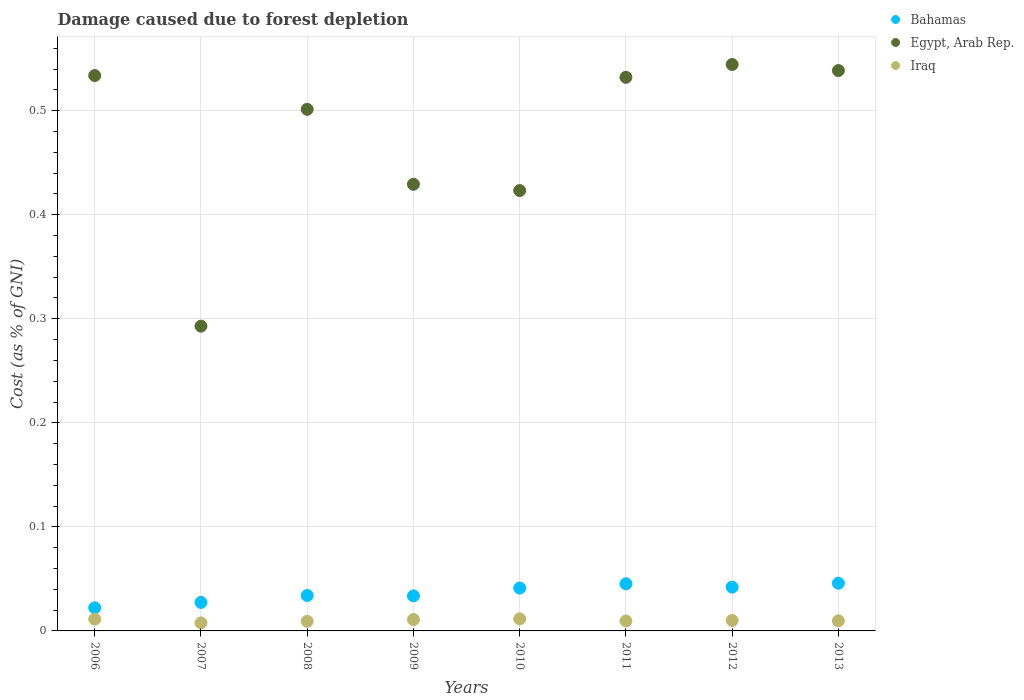How many different coloured dotlines are there?
Your answer should be very brief. 3. What is the cost of damage caused due to forest depletion in Egypt, Arab Rep. in 2011?
Ensure brevity in your answer.  0.53. Across all years, what is the maximum cost of damage caused due to forest depletion in Egypt, Arab Rep.?
Keep it short and to the point. 0.54. Across all years, what is the minimum cost of damage caused due to forest depletion in Egypt, Arab Rep.?
Offer a terse response. 0.29. In which year was the cost of damage caused due to forest depletion in Bahamas minimum?
Your response must be concise. 2006. What is the total cost of damage caused due to forest depletion in Iraq in the graph?
Offer a terse response. 0.08. What is the difference between the cost of damage caused due to forest depletion in Iraq in 2007 and that in 2008?
Provide a short and direct response. -0. What is the difference between the cost of damage caused due to forest depletion in Egypt, Arab Rep. in 2013 and the cost of damage caused due to forest depletion in Iraq in 2009?
Provide a succinct answer. 0.53. What is the average cost of damage caused due to forest depletion in Bahamas per year?
Provide a succinct answer. 0.04. In the year 2012, what is the difference between the cost of damage caused due to forest depletion in Egypt, Arab Rep. and cost of damage caused due to forest depletion in Bahamas?
Offer a very short reply. 0.5. In how many years, is the cost of damage caused due to forest depletion in Egypt, Arab Rep. greater than 0.46 %?
Keep it short and to the point. 5. What is the ratio of the cost of damage caused due to forest depletion in Iraq in 2010 to that in 2013?
Your response must be concise. 1.2. What is the difference between the highest and the second highest cost of damage caused due to forest depletion in Egypt, Arab Rep.?
Your response must be concise. 0.01. What is the difference between the highest and the lowest cost of damage caused due to forest depletion in Iraq?
Ensure brevity in your answer.  0. Is the sum of the cost of damage caused due to forest depletion in Bahamas in 2009 and 2012 greater than the maximum cost of damage caused due to forest depletion in Iraq across all years?
Provide a short and direct response. Yes. Is it the case that in every year, the sum of the cost of damage caused due to forest depletion in Iraq and cost of damage caused due to forest depletion in Egypt, Arab Rep.  is greater than the cost of damage caused due to forest depletion in Bahamas?
Your answer should be very brief. Yes. Is the cost of damage caused due to forest depletion in Egypt, Arab Rep. strictly less than the cost of damage caused due to forest depletion in Iraq over the years?
Offer a very short reply. No. How many dotlines are there?
Make the answer very short. 3. What is the difference between two consecutive major ticks on the Y-axis?
Make the answer very short. 0.1. Are the values on the major ticks of Y-axis written in scientific E-notation?
Keep it short and to the point. No. Does the graph contain grids?
Provide a short and direct response. Yes. Where does the legend appear in the graph?
Offer a very short reply. Top right. What is the title of the graph?
Your response must be concise. Damage caused due to forest depletion. Does "Least developed countries" appear as one of the legend labels in the graph?
Offer a very short reply. No. What is the label or title of the Y-axis?
Offer a very short reply. Cost (as % of GNI). What is the Cost (as % of GNI) in Bahamas in 2006?
Keep it short and to the point. 0.02. What is the Cost (as % of GNI) in Egypt, Arab Rep. in 2006?
Keep it short and to the point. 0.53. What is the Cost (as % of GNI) of Iraq in 2006?
Offer a very short reply. 0.01. What is the Cost (as % of GNI) of Bahamas in 2007?
Provide a short and direct response. 0.03. What is the Cost (as % of GNI) of Egypt, Arab Rep. in 2007?
Offer a very short reply. 0.29. What is the Cost (as % of GNI) in Iraq in 2007?
Give a very brief answer. 0.01. What is the Cost (as % of GNI) in Bahamas in 2008?
Keep it short and to the point. 0.03. What is the Cost (as % of GNI) of Egypt, Arab Rep. in 2008?
Your response must be concise. 0.5. What is the Cost (as % of GNI) in Iraq in 2008?
Your response must be concise. 0.01. What is the Cost (as % of GNI) of Bahamas in 2009?
Give a very brief answer. 0.03. What is the Cost (as % of GNI) in Egypt, Arab Rep. in 2009?
Your answer should be compact. 0.43. What is the Cost (as % of GNI) of Iraq in 2009?
Give a very brief answer. 0.01. What is the Cost (as % of GNI) in Bahamas in 2010?
Provide a succinct answer. 0.04. What is the Cost (as % of GNI) in Egypt, Arab Rep. in 2010?
Offer a terse response. 0.42. What is the Cost (as % of GNI) in Iraq in 2010?
Your response must be concise. 0.01. What is the Cost (as % of GNI) in Bahamas in 2011?
Your answer should be very brief. 0.05. What is the Cost (as % of GNI) of Egypt, Arab Rep. in 2011?
Provide a short and direct response. 0.53. What is the Cost (as % of GNI) in Iraq in 2011?
Give a very brief answer. 0.01. What is the Cost (as % of GNI) of Bahamas in 2012?
Keep it short and to the point. 0.04. What is the Cost (as % of GNI) in Egypt, Arab Rep. in 2012?
Keep it short and to the point. 0.54. What is the Cost (as % of GNI) in Iraq in 2012?
Give a very brief answer. 0.01. What is the Cost (as % of GNI) of Bahamas in 2013?
Offer a very short reply. 0.05. What is the Cost (as % of GNI) in Egypt, Arab Rep. in 2013?
Offer a very short reply. 0.54. What is the Cost (as % of GNI) in Iraq in 2013?
Give a very brief answer. 0.01. Across all years, what is the maximum Cost (as % of GNI) in Bahamas?
Your answer should be compact. 0.05. Across all years, what is the maximum Cost (as % of GNI) in Egypt, Arab Rep.?
Offer a terse response. 0.54. Across all years, what is the maximum Cost (as % of GNI) of Iraq?
Offer a terse response. 0.01. Across all years, what is the minimum Cost (as % of GNI) of Bahamas?
Your response must be concise. 0.02. Across all years, what is the minimum Cost (as % of GNI) of Egypt, Arab Rep.?
Provide a succinct answer. 0.29. Across all years, what is the minimum Cost (as % of GNI) in Iraq?
Your response must be concise. 0.01. What is the total Cost (as % of GNI) in Bahamas in the graph?
Give a very brief answer. 0.29. What is the total Cost (as % of GNI) in Egypt, Arab Rep. in the graph?
Ensure brevity in your answer.  3.8. What is the total Cost (as % of GNI) in Iraq in the graph?
Ensure brevity in your answer.  0.08. What is the difference between the Cost (as % of GNI) in Bahamas in 2006 and that in 2007?
Give a very brief answer. -0.01. What is the difference between the Cost (as % of GNI) in Egypt, Arab Rep. in 2006 and that in 2007?
Provide a short and direct response. 0.24. What is the difference between the Cost (as % of GNI) of Iraq in 2006 and that in 2007?
Your answer should be compact. 0. What is the difference between the Cost (as % of GNI) of Bahamas in 2006 and that in 2008?
Keep it short and to the point. -0.01. What is the difference between the Cost (as % of GNI) in Egypt, Arab Rep. in 2006 and that in 2008?
Your answer should be compact. 0.03. What is the difference between the Cost (as % of GNI) in Iraq in 2006 and that in 2008?
Ensure brevity in your answer.  0. What is the difference between the Cost (as % of GNI) of Bahamas in 2006 and that in 2009?
Your response must be concise. -0.01. What is the difference between the Cost (as % of GNI) in Egypt, Arab Rep. in 2006 and that in 2009?
Your answer should be compact. 0.1. What is the difference between the Cost (as % of GNI) of Iraq in 2006 and that in 2009?
Ensure brevity in your answer.  0. What is the difference between the Cost (as % of GNI) of Bahamas in 2006 and that in 2010?
Offer a terse response. -0.02. What is the difference between the Cost (as % of GNI) in Egypt, Arab Rep. in 2006 and that in 2010?
Keep it short and to the point. 0.11. What is the difference between the Cost (as % of GNI) of Iraq in 2006 and that in 2010?
Provide a short and direct response. -0. What is the difference between the Cost (as % of GNI) of Bahamas in 2006 and that in 2011?
Your response must be concise. -0.02. What is the difference between the Cost (as % of GNI) of Egypt, Arab Rep. in 2006 and that in 2011?
Ensure brevity in your answer.  0. What is the difference between the Cost (as % of GNI) of Iraq in 2006 and that in 2011?
Give a very brief answer. 0. What is the difference between the Cost (as % of GNI) of Bahamas in 2006 and that in 2012?
Offer a very short reply. -0.02. What is the difference between the Cost (as % of GNI) of Egypt, Arab Rep. in 2006 and that in 2012?
Your response must be concise. -0.01. What is the difference between the Cost (as % of GNI) in Iraq in 2006 and that in 2012?
Your answer should be very brief. 0. What is the difference between the Cost (as % of GNI) in Bahamas in 2006 and that in 2013?
Make the answer very short. -0.02. What is the difference between the Cost (as % of GNI) in Egypt, Arab Rep. in 2006 and that in 2013?
Offer a terse response. -0. What is the difference between the Cost (as % of GNI) of Iraq in 2006 and that in 2013?
Provide a short and direct response. 0. What is the difference between the Cost (as % of GNI) in Bahamas in 2007 and that in 2008?
Ensure brevity in your answer.  -0.01. What is the difference between the Cost (as % of GNI) in Egypt, Arab Rep. in 2007 and that in 2008?
Your answer should be very brief. -0.21. What is the difference between the Cost (as % of GNI) of Iraq in 2007 and that in 2008?
Ensure brevity in your answer.  -0. What is the difference between the Cost (as % of GNI) of Bahamas in 2007 and that in 2009?
Make the answer very short. -0.01. What is the difference between the Cost (as % of GNI) of Egypt, Arab Rep. in 2007 and that in 2009?
Give a very brief answer. -0.14. What is the difference between the Cost (as % of GNI) of Iraq in 2007 and that in 2009?
Provide a succinct answer. -0. What is the difference between the Cost (as % of GNI) in Bahamas in 2007 and that in 2010?
Give a very brief answer. -0.01. What is the difference between the Cost (as % of GNI) of Egypt, Arab Rep. in 2007 and that in 2010?
Ensure brevity in your answer.  -0.13. What is the difference between the Cost (as % of GNI) in Iraq in 2007 and that in 2010?
Keep it short and to the point. -0. What is the difference between the Cost (as % of GNI) of Bahamas in 2007 and that in 2011?
Make the answer very short. -0.02. What is the difference between the Cost (as % of GNI) in Egypt, Arab Rep. in 2007 and that in 2011?
Offer a very short reply. -0.24. What is the difference between the Cost (as % of GNI) of Iraq in 2007 and that in 2011?
Make the answer very short. -0. What is the difference between the Cost (as % of GNI) of Bahamas in 2007 and that in 2012?
Provide a short and direct response. -0.01. What is the difference between the Cost (as % of GNI) in Egypt, Arab Rep. in 2007 and that in 2012?
Keep it short and to the point. -0.25. What is the difference between the Cost (as % of GNI) of Iraq in 2007 and that in 2012?
Provide a short and direct response. -0. What is the difference between the Cost (as % of GNI) in Bahamas in 2007 and that in 2013?
Keep it short and to the point. -0.02. What is the difference between the Cost (as % of GNI) in Egypt, Arab Rep. in 2007 and that in 2013?
Keep it short and to the point. -0.25. What is the difference between the Cost (as % of GNI) of Iraq in 2007 and that in 2013?
Offer a very short reply. -0. What is the difference between the Cost (as % of GNI) of Bahamas in 2008 and that in 2009?
Keep it short and to the point. 0. What is the difference between the Cost (as % of GNI) in Egypt, Arab Rep. in 2008 and that in 2009?
Keep it short and to the point. 0.07. What is the difference between the Cost (as % of GNI) of Iraq in 2008 and that in 2009?
Your answer should be compact. -0. What is the difference between the Cost (as % of GNI) of Bahamas in 2008 and that in 2010?
Provide a short and direct response. -0.01. What is the difference between the Cost (as % of GNI) of Egypt, Arab Rep. in 2008 and that in 2010?
Give a very brief answer. 0.08. What is the difference between the Cost (as % of GNI) in Iraq in 2008 and that in 2010?
Make the answer very short. -0. What is the difference between the Cost (as % of GNI) in Bahamas in 2008 and that in 2011?
Offer a terse response. -0.01. What is the difference between the Cost (as % of GNI) in Egypt, Arab Rep. in 2008 and that in 2011?
Your response must be concise. -0.03. What is the difference between the Cost (as % of GNI) in Iraq in 2008 and that in 2011?
Your response must be concise. -0. What is the difference between the Cost (as % of GNI) of Bahamas in 2008 and that in 2012?
Your answer should be compact. -0.01. What is the difference between the Cost (as % of GNI) of Egypt, Arab Rep. in 2008 and that in 2012?
Offer a very short reply. -0.04. What is the difference between the Cost (as % of GNI) of Iraq in 2008 and that in 2012?
Provide a short and direct response. -0. What is the difference between the Cost (as % of GNI) of Bahamas in 2008 and that in 2013?
Provide a succinct answer. -0.01. What is the difference between the Cost (as % of GNI) of Egypt, Arab Rep. in 2008 and that in 2013?
Provide a short and direct response. -0.04. What is the difference between the Cost (as % of GNI) in Iraq in 2008 and that in 2013?
Offer a very short reply. -0. What is the difference between the Cost (as % of GNI) of Bahamas in 2009 and that in 2010?
Keep it short and to the point. -0.01. What is the difference between the Cost (as % of GNI) in Egypt, Arab Rep. in 2009 and that in 2010?
Offer a very short reply. 0.01. What is the difference between the Cost (as % of GNI) in Iraq in 2009 and that in 2010?
Give a very brief answer. -0. What is the difference between the Cost (as % of GNI) in Bahamas in 2009 and that in 2011?
Provide a succinct answer. -0.01. What is the difference between the Cost (as % of GNI) of Egypt, Arab Rep. in 2009 and that in 2011?
Offer a terse response. -0.1. What is the difference between the Cost (as % of GNI) of Iraq in 2009 and that in 2011?
Give a very brief answer. 0. What is the difference between the Cost (as % of GNI) in Bahamas in 2009 and that in 2012?
Your answer should be very brief. -0.01. What is the difference between the Cost (as % of GNI) of Egypt, Arab Rep. in 2009 and that in 2012?
Ensure brevity in your answer.  -0.12. What is the difference between the Cost (as % of GNI) in Iraq in 2009 and that in 2012?
Keep it short and to the point. 0. What is the difference between the Cost (as % of GNI) of Bahamas in 2009 and that in 2013?
Make the answer very short. -0.01. What is the difference between the Cost (as % of GNI) in Egypt, Arab Rep. in 2009 and that in 2013?
Provide a short and direct response. -0.11. What is the difference between the Cost (as % of GNI) of Iraq in 2009 and that in 2013?
Provide a succinct answer. 0. What is the difference between the Cost (as % of GNI) in Bahamas in 2010 and that in 2011?
Give a very brief answer. -0. What is the difference between the Cost (as % of GNI) in Egypt, Arab Rep. in 2010 and that in 2011?
Ensure brevity in your answer.  -0.11. What is the difference between the Cost (as % of GNI) of Iraq in 2010 and that in 2011?
Offer a terse response. 0. What is the difference between the Cost (as % of GNI) in Bahamas in 2010 and that in 2012?
Keep it short and to the point. -0. What is the difference between the Cost (as % of GNI) of Egypt, Arab Rep. in 2010 and that in 2012?
Offer a terse response. -0.12. What is the difference between the Cost (as % of GNI) in Iraq in 2010 and that in 2012?
Provide a succinct answer. 0. What is the difference between the Cost (as % of GNI) in Bahamas in 2010 and that in 2013?
Your answer should be compact. -0. What is the difference between the Cost (as % of GNI) of Egypt, Arab Rep. in 2010 and that in 2013?
Your answer should be compact. -0.12. What is the difference between the Cost (as % of GNI) of Iraq in 2010 and that in 2013?
Offer a very short reply. 0. What is the difference between the Cost (as % of GNI) in Bahamas in 2011 and that in 2012?
Give a very brief answer. 0. What is the difference between the Cost (as % of GNI) in Egypt, Arab Rep. in 2011 and that in 2012?
Provide a succinct answer. -0.01. What is the difference between the Cost (as % of GNI) in Iraq in 2011 and that in 2012?
Keep it short and to the point. -0. What is the difference between the Cost (as % of GNI) in Bahamas in 2011 and that in 2013?
Your response must be concise. -0. What is the difference between the Cost (as % of GNI) in Egypt, Arab Rep. in 2011 and that in 2013?
Provide a short and direct response. -0.01. What is the difference between the Cost (as % of GNI) in Iraq in 2011 and that in 2013?
Offer a terse response. -0. What is the difference between the Cost (as % of GNI) of Bahamas in 2012 and that in 2013?
Keep it short and to the point. -0. What is the difference between the Cost (as % of GNI) in Egypt, Arab Rep. in 2012 and that in 2013?
Ensure brevity in your answer.  0.01. What is the difference between the Cost (as % of GNI) in Bahamas in 2006 and the Cost (as % of GNI) in Egypt, Arab Rep. in 2007?
Keep it short and to the point. -0.27. What is the difference between the Cost (as % of GNI) of Bahamas in 2006 and the Cost (as % of GNI) of Iraq in 2007?
Provide a short and direct response. 0.01. What is the difference between the Cost (as % of GNI) of Egypt, Arab Rep. in 2006 and the Cost (as % of GNI) of Iraq in 2007?
Ensure brevity in your answer.  0.53. What is the difference between the Cost (as % of GNI) of Bahamas in 2006 and the Cost (as % of GNI) of Egypt, Arab Rep. in 2008?
Give a very brief answer. -0.48. What is the difference between the Cost (as % of GNI) of Bahamas in 2006 and the Cost (as % of GNI) of Iraq in 2008?
Your response must be concise. 0.01. What is the difference between the Cost (as % of GNI) in Egypt, Arab Rep. in 2006 and the Cost (as % of GNI) in Iraq in 2008?
Your response must be concise. 0.52. What is the difference between the Cost (as % of GNI) of Bahamas in 2006 and the Cost (as % of GNI) of Egypt, Arab Rep. in 2009?
Make the answer very short. -0.41. What is the difference between the Cost (as % of GNI) of Bahamas in 2006 and the Cost (as % of GNI) of Iraq in 2009?
Your response must be concise. 0.01. What is the difference between the Cost (as % of GNI) of Egypt, Arab Rep. in 2006 and the Cost (as % of GNI) of Iraq in 2009?
Provide a short and direct response. 0.52. What is the difference between the Cost (as % of GNI) of Bahamas in 2006 and the Cost (as % of GNI) of Egypt, Arab Rep. in 2010?
Your response must be concise. -0.4. What is the difference between the Cost (as % of GNI) in Bahamas in 2006 and the Cost (as % of GNI) in Iraq in 2010?
Offer a very short reply. 0.01. What is the difference between the Cost (as % of GNI) of Egypt, Arab Rep. in 2006 and the Cost (as % of GNI) of Iraq in 2010?
Make the answer very short. 0.52. What is the difference between the Cost (as % of GNI) of Bahamas in 2006 and the Cost (as % of GNI) of Egypt, Arab Rep. in 2011?
Provide a short and direct response. -0.51. What is the difference between the Cost (as % of GNI) in Bahamas in 2006 and the Cost (as % of GNI) in Iraq in 2011?
Make the answer very short. 0.01. What is the difference between the Cost (as % of GNI) of Egypt, Arab Rep. in 2006 and the Cost (as % of GNI) of Iraq in 2011?
Give a very brief answer. 0.52. What is the difference between the Cost (as % of GNI) in Bahamas in 2006 and the Cost (as % of GNI) in Egypt, Arab Rep. in 2012?
Provide a succinct answer. -0.52. What is the difference between the Cost (as % of GNI) of Bahamas in 2006 and the Cost (as % of GNI) of Iraq in 2012?
Keep it short and to the point. 0.01. What is the difference between the Cost (as % of GNI) in Egypt, Arab Rep. in 2006 and the Cost (as % of GNI) in Iraq in 2012?
Provide a short and direct response. 0.52. What is the difference between the Cost (as % of GNI) in Bahamas in 2006 and the Cost (as % of GNI) in Egypt, Arab Rep. in 2013?
Ensure brevity in your answer.  -0.52. What is the difference between the Cost (as % of GNI) of Bahamas in 2006 and the Cost (as % of GNI) of Iraq in 2013?
Make the answer very short. 0.01. What is the difference between the Cost (as % of GNI) of Egypt, Arab Rep. in 2006 and the Cost (as % of GNI) of Iraq in 2013?
Keep it short and to the point. 0.52. What is the difference between the Cost (as % of GNI) in Bahamas in 2007 and the Cost (as % of GNI) in Egypt, Arab Rep. in 2008?
Ensure brevity in your answer.  -0.47. What is the difference between the Cost (as % of GNI) of Bahamas in 2007 and the Cost (as % of GNI) of Iraq in 2008?
Make the answer very short. 0.02. What is the difference between the Cost (as % of GNI) in Egypt, Arab Rep. in 2007 and the Cost (as % of GNI) in Iraq in 2008?
Provide a short and direct response. 0.28. What is the difference between the Cost (as % of GNI) in Bahamas in 2007 and the Cost (as % of GNI) in Egypt, Arab Rep. in 2009?
Make the answer very short. -0.4. What is the difference between the Cost (as % of GNI) in Bahamas in 2007 and the Cost (as % of GNI) in Iraq in 2009?
Keep it short and to the point. 0.02. What is the difference between the Cost (as % of GNI) of Egypt, Arab Rep. in 2007 and the Cost (as % of GNI) of Iraq in 2009?
Offer a very short reply. 0.28. What is the difference between the Cost (as % of GNI) in Bahamas in 2007 and the Cost (as % of GNI) in Egypt, Arab Rep. in 2010?
Provide a short and direct response. -0.4. What is the difference between the Cost (as % of GNI) of Bahamas in 2007 and the Cost (as % of GNI) of Iraq in 2010?
Offer a terse response. 0.02. What is the difference between the Cost (as % of GNI) in Egypt, Arab Rep. in 2007 and the Cost (as % of GNI) in Iraq in 2010?
Give a very brief answer. 0.28. What is the difference between the Cost (as % of GNI) in Bahamas in 2007 and the Cost (as % of GNI) in Egypt, Arab Rep. in 2011?
Provide a short and direct response. -0.5. What is the difference between the Cost (as % of GNI) in Bahamas in 2007 and the Cost (as % of GNI) in Iraq in 2011?
Ensure brevity in your answer.  0.02. What is the difference between the Cost (as % of GNI) in Egypt, Arab Rep. in 2007 and the Cost (as % of GNI) in Iraq in 2011?
Offer a terse response. 0.28. What is the difference between the Cost (as % of GNI) in Bahamas in 2007 and the Cost (as % of GNI) in Egypt, Arab Rep. in 2012?
Offer a very short reply. -0.52. What is the difference between the Cost (as % of GNI) in Bahamas in 2007 and the Cost (as % of GNI) in Iraq in 2012?
Give a very brief answer. 0.02. What is the difference between the Cost (as % of GNI) in Egypt, Arab Rep. in 2007 and the Cost (as % of GNI) in Iraq in 2012?
Offer a terse response. 0.28. What is the difference between the Cost (as % of GNI) in Bahamas in 2007 and the Cost (as % of GNI) in Egypt, Arab Rep. in 2013?
Your answer should be very brief. -0.51. What is the difference between the Cost (as % of GNI) in Bahamas in 2007 and the Cost (as % of GNI) in Iraq in 2013?
Provide a succinct answer. 0.02. What is the difference between the Cost (as % of GNI) of Egypt, Arab Rep. in 2007 and the Cost (as % of GNI) of Iraq in 2013?
Your answer should be very brief. 0.28. What is the difference between the Cost (as % of GNI) of Bahamas in 2008 and the Cost (as % of GNI) of Egypt, Arab Rep. in 2009?
Your answer should be very brief. -0.4. What is the difference between the Cost (as % of GNI) of Bahamas in 2008 and the Cost (as % of GNI) of Iraq in 2009?
Your answer should be very brief. 0.02. What is the difference between the Cost (as % of GNI) of Egypt, Arab Rep. in 2008 and the Cost (as % of GNI) of Iraq in 2009?
Your answer should be very brief. 0.49. What is the difference between the Cost (as % of GNI) in Bahamas in 2008 and the Cost (as % of GNI) in Egypt, Arab Rep. in 2010?
Keep it short and to the point. -0.39. What is the difference between the Cost (as % of GNI) of Bahamas in 2008 and the Cost (as % of GNI) of Iraq in 2010?
Provide a short and direct response. 0.02. What is the difference between the Cost (as % of GNI) of Egypt, Arab Rep. in 2008 and the Cost (as % of GNI) of Iraq in 2010?
Ensure brevity in your answer.  0.49. What is the difference between the Cost (as % of GNI) of Bahamas in 2008 and the Cost (as % of GNI) of Egypt, Arab Rep. in 2011?
Provide a succinct answer. -0.5. What is the difference between the Cost (as % of GNI) of Bahamas in 2008 and the Cost (as % of GNI) of Iraq in 2011?
Offer a terse response. 0.02. What is the difference between the Cost (as % of GNI) of Egypt, Arab Rep. in 2008 and the Cost (as % of GNI) of Iraq in 2011?
Your answer should be very brief. 0.49. What is the difference between the Cost (as % of GNI) of Bahamas in 2008 and the Cost (as % of GNI) of Egypt, Arab Rep. in 2012?
Provide a short and direct response. -0.51. What is the difference between the Cost (as % of GNI) in Bahamas in 2008 and the Cost (as % of GNI) in Iraq in 2012?
Provide a succinct answer. 0.02. What is the difference between the Cost (as % of GNI) in Egypt, Arab Rep. in 2008 and the Cost (as % of GNI) in Iraq in 2012?
Your answer should be compact. 0.49. What is the difference between the Cost (as % of GNI) of Bahamas in 2008 and the Cost (as % of GNI) of Egypt, Arab Rep. in 2013?
Offer a terse response. -0.5. What is the difference between the Cost (as % of GNI) in Bahamas in 2008 and the Cost (as % of GNI) in Iraq in 2013?
Provide a succinct answer. 0.02. What is the difference between the Cost (as % of GNI) of Egypt, Arab Rep. in 2008 and the Cost (as % of GNI) of Iraq in 2013?
Make the answer very short. 0.49. What is the difference between the Cost (as % of GNI) in Bahamas in 2009 and the Cost (as % of GNI) in Egypt, Arab Rep. in 2010?
Ensure brevity in your answer.  -0.39. What is the difference between the Cost (as % of GNI) in Bahamas in 2009 and the Cost (as % of GNI) in Iraq in 2010?
Your answer should be very brief. 0.02. What is the difference between the Cost (as % of GNI) of Egypt, Arab Rep. in 2009 and the Cost (as % of GNI) of Iraq in 2010?
Offer a terse response. 0.42. What is the difference between the Cost (as % of GNI) of Bahamas in 2009 and the Cost (as % of GNI) of Egypt, Arab Rep. in 2011?
Keep it short and to the point. -0.5. What is the difference between the Cost (as % of GNI) in Bahamas in 2009 and the Cost (as % of GNI) in Iraq in 2011?
Provide a succinct answer. 0.02. What is the difference between the Cost (as % of GNI) of Egypt, Arab Rep. in 2009 and the Cost (as % of GNI) of Iraq in 2011?
Your response must be concise. 0.42. What is the difference between the Cost (as % of GNI) of Bahamas in 2009 and the Cost (as % of GNI) of Egypt, Arab Rep. in 2012?
Offer a terse response. -0.51. What is the difference between the Cost (as % of GNI) in Bahamas in 2009 and the Cost (as % of GNI) in Iraq in 2012?
Your answer should be very brief. 0.02. What is the difference between the Cost (as % of GNI) of Egypt, Arab Rep. in 2009 and the Cost (as % of GNI) of Iraq in 2012?
Offer a terse response. 0.42. What is the difference between the Cost (as % of GNI) of Bahamas in 2009 and the Cost (as % of GNI) of Egypt, Arab Rep. in 2013?
Provide a succinct answer. -0.5. What is the difference between the Cost (as % of GNI) in Bahamas in 2009 and the Cost (as % of GNI) in Iraq in 2013?
Your answer should be compact. 0.02. What is the difference between the Cost (as % of GNI) in Egypt, Arab Rep. in 2009 and the Cost (as % of GNI) in Iraq in 2013?
Your answer should be compact. 0.42. What is the difference between the Cost (as % of GNI) of Bahamas in 2010 and the Cost (as % of GNI) of Egypt, Arab Rep. in 2011?
Provide a short and direct response. -0.49. What is the difference between the Cost (as % of GNI) in Bahamas in 2010 and the Cost (as % of GNI) in Iraq in 2011?
Keep it short and to the point. 0.03. What is the difference between the Cost (as % of GNI) in Egypt, Arab Rep. in 2010 and the Cost (as % of GNI) in Iraq in 2011?
Ensure brevity in your answer.  0.41. What is the difference between the Cost (as % of GNI) in Bahamas in 2010 and the Cost (as % of GNI) in Egypt, Arab Rep. in 2012?
Give a very brief answer. -0.5. What is the difference between the Cost (as % of GNI) in Bahamas in 2010 and the Cost (as % of GNI) in Iraq in 2012?
Ensure brevity in your answer.  0.03. What is the difference between the Cost (as % of GNI) in Egypt, Arab Rep. in 2010 and the Cost (as % of GNI) in Iraq in 2012?
Offer a terse response. 0.41. What is the difference between the Cost (as % of GNI) of Bahamas in 2010 and the Cost (as % of GNI) of Egypt, Arab Rep. in 2013?
Provide a succinct answer. -0.5. What is the difference between the Cost (as % of GNI) in Bahamas in 2010 and the Cost (as % of GNI) in Iraq in 2013?
Your answer should be compact. 0.03. What is the difference between the Cost (as % of GNI) of Egypt, Arab Rep. in 2010 and the Cost (as % of GNI) of Iraq in 2013?
Your answer should be very brief. 0.41. What is the difference between the Cost (as % of GNI) of Bahamas in 2011 and the Cost (as % of GNI) of Egypt, Arab Rep. in 2012?
Offer a very short reply. -0.5. What is the difference between the Cost (as % of GNI) in Bahamas in 2011 and the Cost (as % of GNI) in Iraq in 2012?
Ensure brevity in your answer.  0.04. What is the difference between the Cost (as % of GNI) in Egypt, Arab Rep. in 2011 and the Cost (as % of GNI) in Iraq in 2012?
Give a very brief answer. 0.52. What is the difference between the Cost (as % of GNI) in Bahamas in 2011 and the Cost (as % of GNI) in Egypt, Arab Rep. in 2013?
Give a very brief answer. -0.49. What is the difference between the Cost (as % of GNI) of Bahamas in 2011 and the Cost (as % of GNI) of Iraq in 2013?
Offer a terse response. 0.04. What is the difference between the Cost (as % of GNI) in Egypt, Arab Rep. in 2011 and the Cost (as % of GNI) in Iraq in 2013?
Keep it short and to the point. 0.52. What is the difference between the Cost (as % of GNI) in Bahamas in 2012 and the Cost (as % of GNI) in Egypt, Arab Rep. in 2013?
Provide a succinct answer. -0.5. What is the difference between the Cost (as % of GNI) in Bahamas in 2012 and the Cost (as % of GNI) in Iraq in 2013?
Offer a terse response. 0.03. What is the difference between the Cost (as % of GNI) in Egypt, Arab Rep. in 2012 and the Cost (as % of GNI) in Iraq in 2013?
Make the answer very short. 0.53. What is the average Cost (as % of GNI) of Bahamas per year?
Give a very brief answer. 0.04. What is the average Cost (as % of GNI) in Egypt, Arab Rep. per year?
Your answer should be very brief. 0.47. What is the average Cost (as % of GNI) of Iraq per year?
Ensure brevity in your answer.  0.01. In the year 2006, what is the difference between the Cost (as % of GNI) in Bahamas and Cost (as % of GNI) in Egypt, Arab Rep.?
Your answer should be compact. -0.51. In the year 2006, what is the difference between the Cost (as % of GNI) of Bahamas and Cost (as % of GNI) of Iraq?
Your answer should be very brief. 0.01. In the year 2006, what is the difference between the Cost (as % of GNI) of Egypt, Arab Rep. and Cost (as % of GNI) of Iraq?
Provide a succinct answer. 0.52. In the year 2007, what is the difference between the Cost (as % of GNI) in Bahamas and Cost (as % of GNI) in Egypt, Arab Rep.?
Provide a short and direct response. -0.27. In the year 2007, what is the difference between the Cost (as % of GNI) in Bahamas and Cost (as % of GNI) in Iraq?
Offer a very short reply. 0.02. In the year 2007, what is the difference between the Cost (as % of GNI) in Egypt, Arab Rep. and Cost (as % of GNI) in Iraq?
Your answer should be compact. 0.29. In the year 2008, what is the difference between the Cost (as % of GNI) of Bahamas and Cost (as % of GNI) of Egypt, Arab Rep.?
Give a very brief answer. -0.47. In the year 2008, what is the difference between the Cost (as % of GNI) in Bahamas and Cost (as % of GNI) in Iraq?
Your response must be concise. 0.02. In the year 2008, what is the difference between the Cost (as % of GNI) of Egypt, Arab Rep. and Cost (as % of GNI) of Iraq?
Offer a very short reply. 0.49. In the year 2009, what is the difference between the Cost (as % of GNI) in Bahamas and Cost (as % of GNI) in Egypt, Arab Rep.?
Give a very brief answer. -0.4. In the year 2009, what is the difference between the Cost (as % of GNI) of Bahamas and Cost (as % of GNI) of Iraq?
Keep it short and to the point. 0.02. In the year 2009, what is the difference between the Cost (as % of GNI) of Egypt, Arab Rep. and Cost (as % of GNI) of Iraq?
Give a very brief answer. 0.42. In the year 2010, what is the difference between the Cost (as % of GNI) of Bahamas and Cost (as % of GNI) of Egypt, Arab Rep.?
Your answer should be compact. -0.38. In the year 2010, what is the difference between the Cost (as % of GNI) of Bahamas and Cost (as % of GNI) of Iraq?
Offer a terse response. 0.03. In the year 2010, what is the difference between the Cost (as % of GNI) in Egypt, Arab Rep. and Cost (as % of GNI) in Iraq?
Your answer should be compact. 0.41. In the year 2011, what is the difference between the Cost (as % of GNI) in Bahamas and Cost (as % of GNI) in Egypt, Arab Rep.?
Keep it short and to the point. -0.49. In the year 2011, what is the difference between the Cost (as % of GNI) of Bahamas and Cost (as % of GNI) of Iraq?
Offer a terse response. 0.04. In the year 2011, what is the difference between the Cost (as % of GNI) of Egypt, Arab Rep. and Cost (as % of GNI) of Iraq?
Offer a very short reply. 0.52. In the year 2012, what is the difference between the Cost (as % of GNI) in Bahamas and Cost (as % of GNI) in Egypt, Arab Rep.?
Provide a succinct answer. -0.5. In the year 2012, what is the difference between the Cost (as % of GNI) of Bahamas and Cost (as % of GNI) of Iraq?
Give a very brief answer. 0.03. In the year 2012, what is the difference between the Cost (as % of GNI) in Egypt, Arab Rep. and Cost (as % of GNI) in Iraq?
Provide a succinct answer. 0.53. In the year 2013, what is the difference between the Cost (as % of GNI) of Bahamas and Cost (as % of GNI) of Egypt, Arab Rep.?
Offer a very short reply. -0.49. In the year 2013, what is the difference between the Cost (as % of GNI) of Bahamas and Cost (as % of GNI) of Iraq?
Your answer should be compact. 0.04. In the year 2013, what is the difference between the Cost (as % of GNI) of Egypt, Arab Rep. and Cost (as % of GNI) of Iraq?
Make the answer very short. 0.53. What is the ratio of the Cost (as % of GNI) in Bahamas in 2006 to that in 2007?
Provide a succinct answer. 0.81. What is the ratio of the Cost (as % of GNI) of Egypt, Arab Rep. in 2006 to that in 2007?
Your answer should be very brief. 1.82. What is the ratio of the Cost (as % of GNI) in Iraq in 2006 to that in 2007?
Make the answer very short. 1.47. What is the ratio of the Cost (as % of GNI) of Bahamas in 2006 to that in 2008?
Offer a terse response. 0.65. What is the ratio of the Cost (as % of GNI) in Egypt, Arab Rep. in 2006 to that in 2008?
Your answer should be very brief. 1.06. What is the ratio of the Cost (as % of GNI) of Iraq in 2006 to that in 2008?
Your answer should be very brief. 1.23. What is the ratio of the Cost (as % of GNI) of Bahamas in 2006 to that in 2009?
Your response must be concise. 0.66. What is the ratio of the Cost (as % of GNI) in Egypt, Arab Rep. in 2006 to that in 2009?
Provide a succinct answer. 1.24. What is the ratio of the Cost (as % of GNI) in Iraq in 2006 to that in 2009?
Your response must be concise. 1.03. What is the ratio of the Cost (as % of GNI) in Bahamas in 2006 to that in 2010?
Keep it short and to the point. 0.54. What is the ratio of the Cost (as % of GNI) in Egypt, Arab Rep. in 2006 to that in 2010?
Your answer should be compact. 1.26. What is the ratio of the Cost (as % of GNI) in Iraq in 2006 to that in 2010?
Offer a very short reply. 0.98. What is the ratio of the Cost (as % of GNI) of Bahamas in 2006 to that in 2011?
Your answer should be very brief. 0.49. What is the ratio of the Cost (as % of GNI) in Egypt, Arab Rep. in 2006 to that in 2011?
Make the answer very short. 1. What is the ratio of the Cost (as % of GNI) in Iraq in 2006 to that in 2011?
Your response must be concise. 1.19. What is the ratio of the Cost (as % of GNI) of Bahamas in 2006 to that in 2012?
Your answer should be very brief. 0.53. What is the ratio of the Cost (as % of GNI) in Egypt, Arab Rep. in 2006 to that in 2012?
Offer a very short reply. 0.98. What is the ratio of the Cost (as % of GNI) of Iraq in 2006 to that in 2012?
Your answer should be compact. 1.13. What is the ratio of the Cost (as % of GNI) of Bahamas in 2006 to that in 2013?
Your response must be concise. 0.48. What is the ratio of the Cost (as % of GNI) in Iraq in 2006 to that in 2013?
Ensure brevity in your answer.  1.17. What is the ratio of the Cost (as % of GNI) in Bahamas in 2007 to that in 2008?
Give a very brief answer. 0.8. What is the ratio of the Cost (as % of GNI) in Egypt, Arab Rep. in 2007 to that in 2008?
Ensure brevity in your answer.  0.58. What is the ratio of the Cost (as % of GNI) in Iraq in 2007 to that in 2008?
Offer a very short reply. 0.84. What is the ratio of the Cost (as % of GNI) of Bahamas in 2007 to that in 2009?
Give a very brief answer. 0.81. What is the ratio of the Cost (as % of GNI) in Egypt, Arab Rep. in 2007 to that in 2009?
Offer a terse response. 0.68. What is the ratio of the Cost (as % of GNI) in Iraq in 2007 to that in 2009?
Provide a short and direct response. 0.7. What is the ratio of the Cost (as % of GNI) of Bahamas in 2007 to that in 2010?
Provide a short and direct response. 0.67. What is the ratio of the Cost (as % of GNI) in Egypt, Arab Rep. in 2007 to that in 2010?
Your response must be concise. 0.69. What is the ratio of the Cost (as % of GNI) in Iraq in 2007 to that in 2010?
Give a very brief answer. 0.67. What is the ratio of the Cost (as % of GNI) in Bahamas in 2007 to that in 2011?
Your answer should be very brief. 0.6. What is the ratio of the Cost (as % of GNI) of Egypt, Arab Rep. in 2007 to that in 2011?
Your answer should be very brief. 0.55. What is the ratio of the Cost (as % of GNI) of Iraq in 2007 to that in 2011?
Your response must be concise. 0.81. What is the ratio of the Cost (as % of GNI) in Bahamas in 2007 to that in 2012?
Your answer should be compact. 0.65. What is the ratio of the Cost (as % of GNI) of Egypt, Arab Rep. in 2007 to that in 2012?
Offer a terse response. 0.54. What is the ratio of the Cost (as % of GNI) of Iraq in 2007 to that in 2012?
Provide a succinct answer. 0.77. What is the ratio of the Cost (as % of GNI) of Bahamas in 2007 to that in 2013?
Your answer should be very brief. 0.6. What is the ratio of the Cost (as % of GNI) of Egypt, Arab Rep. in 2007 to that in 2013?
Ensure brevity in your answer.  0.54. What is the ratio of the Cost (as % of GNI) of Iraq in 2007 to that in 2013?
Ensure brevity in your answer.  0.8. What is the ratio of the Cost (as % of GNI) of Bahamas in 2008 to that in 2009?
Provide a succinct answer. 1.01. What is the ratio of the Cost (as % of GNI) in Egypt, Arab Rep. in 2008 to that in 2009?
Your response must be concise. 1.17. What is the ratio of the Cost (as % of GNI) in Iraq in 2008 to that in 2009?
Offer a terse response. 0.84. What is the ratio of the Cost (as % of GNI) in Bahamas in 2008 to that in 2010?
Keep it short and to the point. 0.83. What is the ratio of the Cost (as % of GNI) of Egypt, Arab Rep. in 2008 to that in 2010?
Offer a terse response. 1.18. What is the ratio of the Cost (as % of GNI) of Iraq in 2008 to that in 2010?
Offer a terse response. 0.8. What is the ratio of the Cost (as % of GNI) in Bahamas in 2008 to that in 2011?
Ensure brevity in your answer.  0.75. What is the ratio of the Cost (as % of GNI) of Egypt, Arab Rep. in 2008 to that in 2011?
Keep it short and to the point. 0.94. What is the ratio of the Cost (as % of GNI) in Iraq in 2008 to that in 2011?
Keep it short and to the point. 0.97. What is the ratio of the Cost (as % of GNI) in Bahamas in 2008 to that in 2012?
Keep it short and to the point. 0.81. What is the ratio of the Cost (as % of GNI) in Egypt, Arab Rep. in 2008 to that in 2012?
Your answer should be very brief. 0.92. What is the ratio of the Cost (as % of GNI) in Iraq in 2008 to that in 2012?
Your response must be concise. 0.92. What is the ratio of the Cost (as % of GNI) of Bahamas in 2008 to that in 2013?
Your answer should be compact. 0.74. What is the ratio of the Cost (as % of GNI) in Egypt, Arab Rep. in 2008 to that in 2013?
Your response must be concise. 0.93. What is the ratio of the Cost (as % of GNI) in Iraq in 2008 to that in 2013?
Your response must be concise. 0.95. What is the ratio of the Cost (as % of GNI) in Bahamas in 2009 to that in 2010?
Your answer should be compact. 0.82. What is the ratio of the Cost (as % of GNI) of Egypt, Arab Rep. in 2009 to that in 2010?
Ensure brevity in your answer.  1.01. What is the ratio of the Cost (as % of GNI) in Iraq in 2009 to that in 2010?
Keep it short and to the point. 0.95. What is the ratio of the Cost (as % of GNI) of Bahamas in 2009 to that in 2011?
Keep it short and to the point. 0.74. What is the ratio of the Cost (as % of GNI) in Egypt, Arab Rep. in 2009 to that in 2011?
Provide a short and direct response. 0.81. What is the ratio of the Cost (as % of GNI) in Iraq in 2009 to that in 2011?
Provide a short and direct response. 1.15. What is the ratio of the Cost (as % of GNI) of Bahamas in 2009 to that in 2012?
Your answer should be compact. 0.8. What is the ratio of the Cost (as % of GNI) of Egypt, Arab Rep. in 2009 to that in 2012?
Your answer should be very brief. 0.79. What is the ratio of the Cost (as % of GNI) in Iraq in 2009 to that in 2012?
Offer a very short reply. 1.09. What is the ratio of the Cost (as % of GNI) in Bahamas in 2009 to that in 2013?
Your answer should be compact. 0.74. What is the ratio of the Cost (as % of GNI) in Egypt, Arab Rep. in 2009 to that in 2013?
Your answer should be very brief. 0.8. What is the ratio of the Cost (as % of GNI) in Iraq in 2009 to that in 2013?
Your answer should be very brief. 1.13. What is the ratio of the Cost (as % of GNI) of Bahamas in 2010 to that in 2011?
Your response must be concise. 0.91. What is the ratio of the Cost (as % of GNI) of Egypt, Arab Rep. in 2010 to that in 2011?
Your answer should be very brief. 0.8. What is the ratio of the Cost (as % of GNI) of Iraq in 2010 to that in 2011?
Keep it short and to the point. 1.22. What is the ratio of the Cost (as % of GNI) in Bahamas in 2010 to that in 2012?
Your answer should be very brief. 0.98. What is the ratio of the Cost (as % of GNI) of Egypt, Arab Rep. in 2010 to that in 2012?
Provide a short and direct response. 0.78. What is the ratio of the Cost (as % of GNI) of Iraq in 2010 to that in 2012?
Keep it short and to the point. 1.15. What is the ratio of the Cost (as % of GNI) of Bahamas in 2010 to that in 2013?
Keep it short and to the point. 0.9. What is the ratio of the Cost (as % of GNI) of Egypt, Arab Rep. in 2010 to that in 2013?
Provide a short and direct response. 0.79. What is the ratio of the Cost (as % of GNI) of Iraq in 2010 to that in 2013?
Keep it short and to the point. 1.2. What is the ratio of the Cost (as % of GNI) of Bahamas in 2011 to that in 2012?
Provide a short and direct response. 1.08. What is the ratio of the Cost (as % of GNI) in Egypt, Arab Rep. in 2011 to that in 2012?
Your answer should be compact. 0.98. What is the ratio of the Cost (as % of GNI) in Iraq in 2011 to that in 2012?
Ensure brevity in your answer.  0.95. What is the ratio of the Cost (as % of GNI) of Bahamas in 2011 to that in 2013?
Your response must be concise. 0.99. What is the ratio of the Cost (as % of GNI) of Egypt, Arab Rep. in 2011 to that in 2013?
Ensure brevity in your answer.  0.99. What is the ratio of the Cost (as % of GNI) in Iraq in 2011 to that in 2013?
Provide a short and direct response. 0.98. What is the ratio of the Cost (as % of GNI) in Bahamas in 2012 to that in 2013?
Your answer should be very brief. 0.92. What is the ratio of the Cost (as % of GNI) in Egypt, Arab Rep. in 2012 to that in 2013?
Provide a short and direct response. 1.01. What is the ratio of the Cost (as % of GNI) of Iraq in 2012 to that in 2013?
Offer a terse response. 1.04. What is the difference between the highest and the second highest Cost (as % of GNI) in Bahamas?
Provide a short and direct response. 0. What is the difference between the highest and the second highest Cost (as % of GNI) in Egypt, Arab Rep.?
Provide a succinct answer. 0.01. What is the difference between the highest and the lowest Cost (as % of GNI) of Bahamas?
Make the answer very short. 0.02. What is the difference between the highest and the lowest Cost (as % of GNI) in Egypt, Arab Rep.?
Offer a very short reply. 0.25. What is the difference between the highest and the lowest Cost (as % of GNI) of Iraq?
Offer a terse response. 0. 